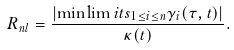<formula> <loc_0><loc_0><loc_500><loc_500>R _ { n l } = \frac { \left | \min \lim i t s _ { 1 \leq i \leq n } \gamma _ { i } ( \tau , t ) \right | } { \kappa ( t ) } .</formula> 